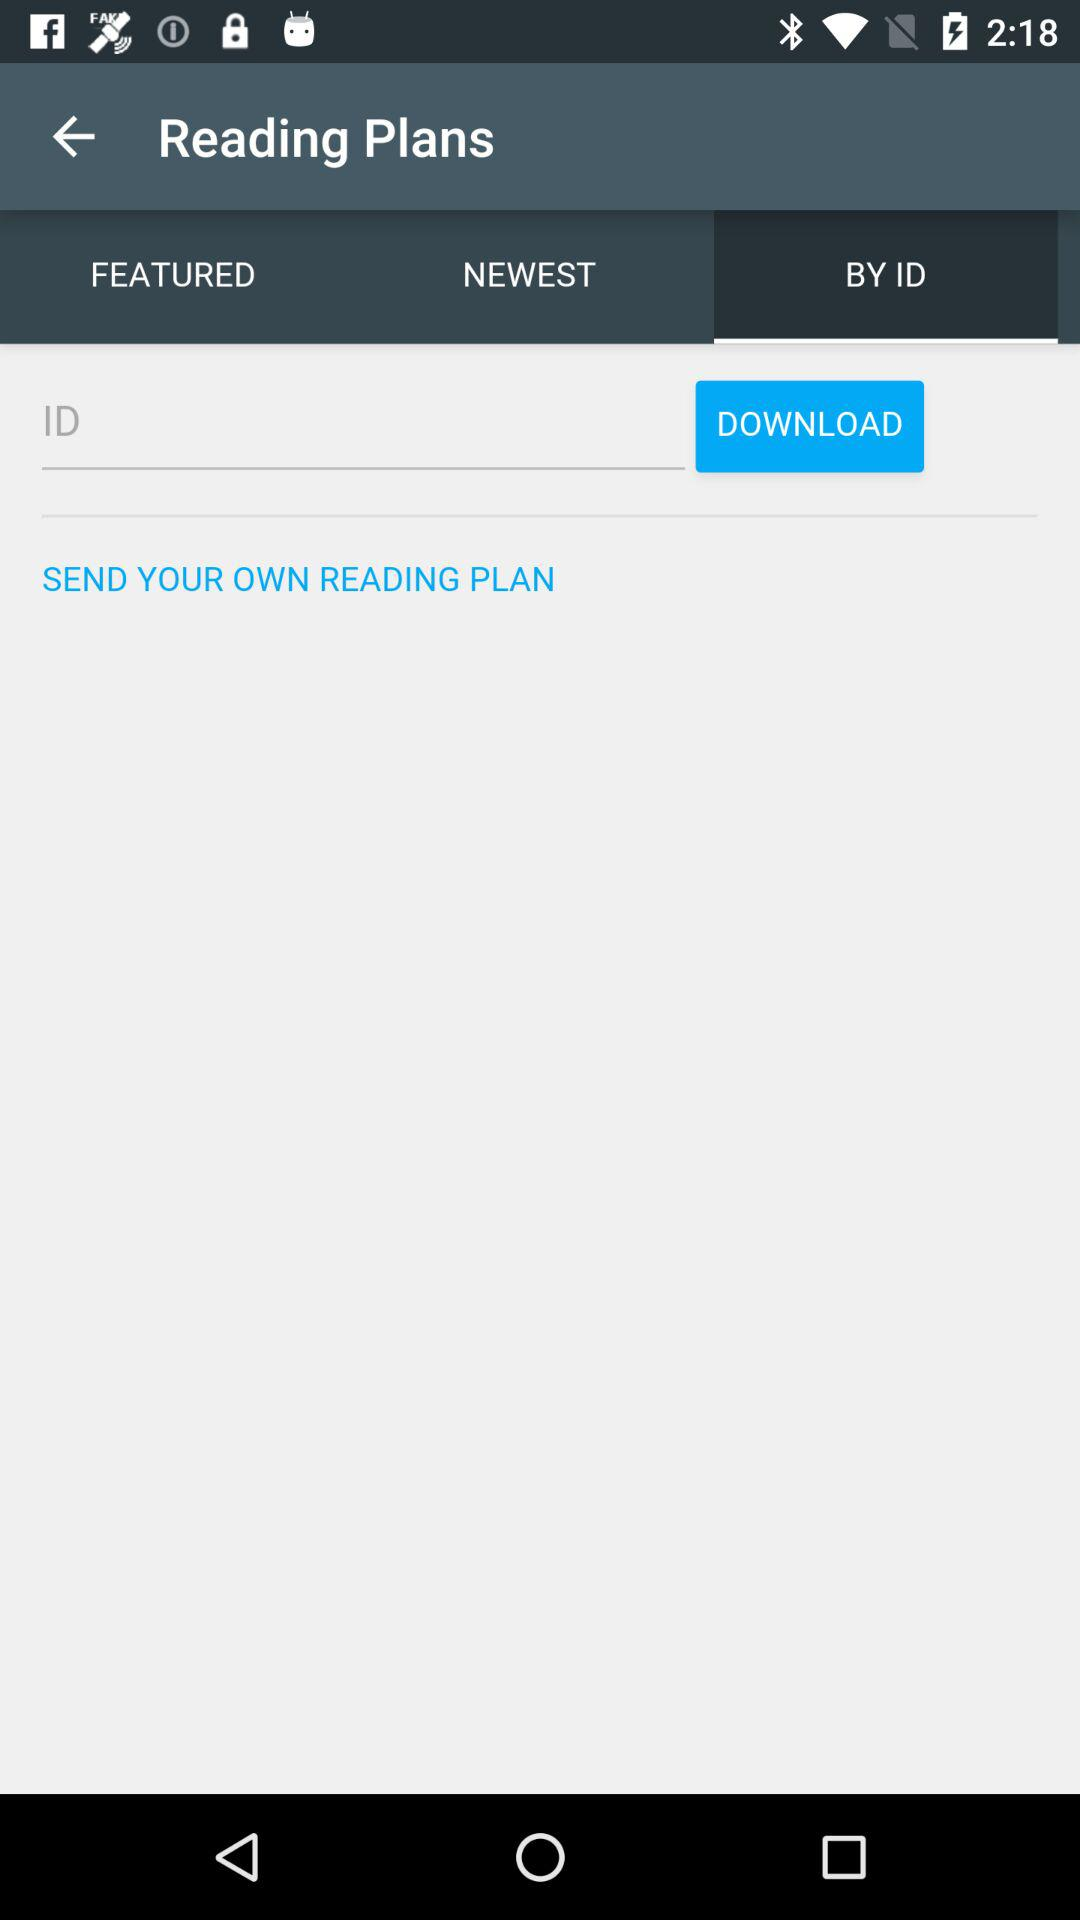Which tab is selected? The selected tab is "BY ID". 